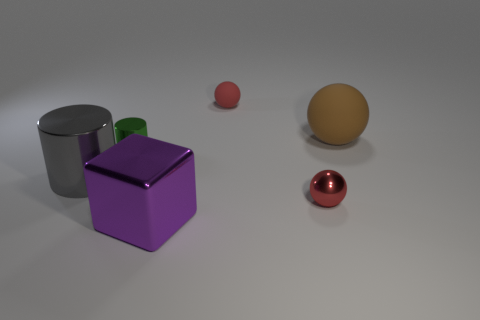Does the gray metallic object have the same shape as the tiny object that is on the left side of the purple thing?
Your answer should be very brief. Yes. Is there a large brown sphere that has the same material as the small cylinder?
Keep it short and to the point. No. There is a small red thing that is on the right side of the tiny sphere behind the green object; is there a big purple object that is to the right of it?
Your response must be concise. No. What number of other objects are the same shape as the small matte thing?
Provide a succinct answer. 2. What is the color of the rubber thing that is right of the small red sphere behind the large shiny object that is on the left side of the purple shiny block?
Make the answer very short. Brown. What number of cyan rubber objects are there?
Keep it short and to the point. 0. How many small objects are red objects or red rubber objects?
Make the answer very short. 2. What is the shape of the purple shiny object that is the same size as the gray cylinder?
Offer a very short reply. Cube. There is a small red ball that is behind the red thing that is in front of the gray shiny object; what is it made of?
Provide a short and direct response. Rubber. Do the red metallic ball and the gray shiny thing have the same size?
Offer a terse response. No. 